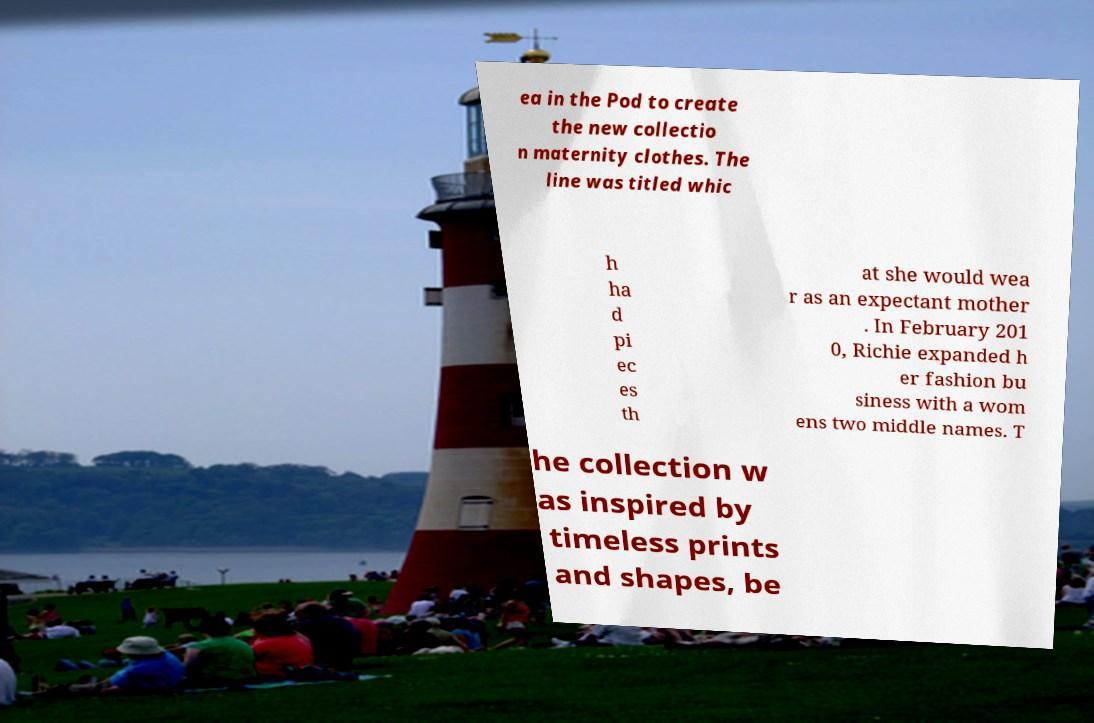For documentation purposes, I need the text within this image transcribed. Could you provide that? ea in the Pod to create the new collectio n maternity clothes. The line was titled whic h ha d pi ec es th at she would wea r as an expectant mother . In February 201 0, Richie expanded h er fashion bu siness with a wom ens two middle names. T he collection w as inspired by timeless prints and shapes, be 